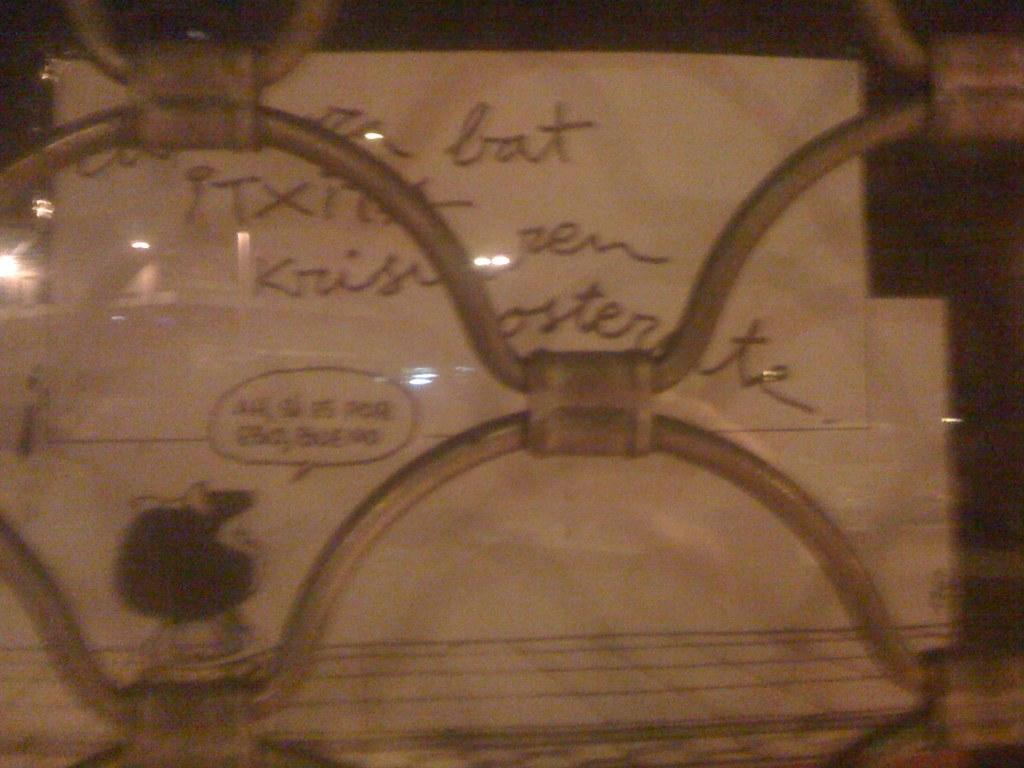What is on the board that is visible in the image? There is a board with text in the image. Where might the image have been taken from? The image appears to be taken from a vehicle. What can be seen in the middle of the image? There is a metal grill in the middle of the image. What type of chess pieces are on the board in the image? There are no chess pieces present in the image; it features a board with text. Is there a bag visible in the image? There is no bag present in the image. 